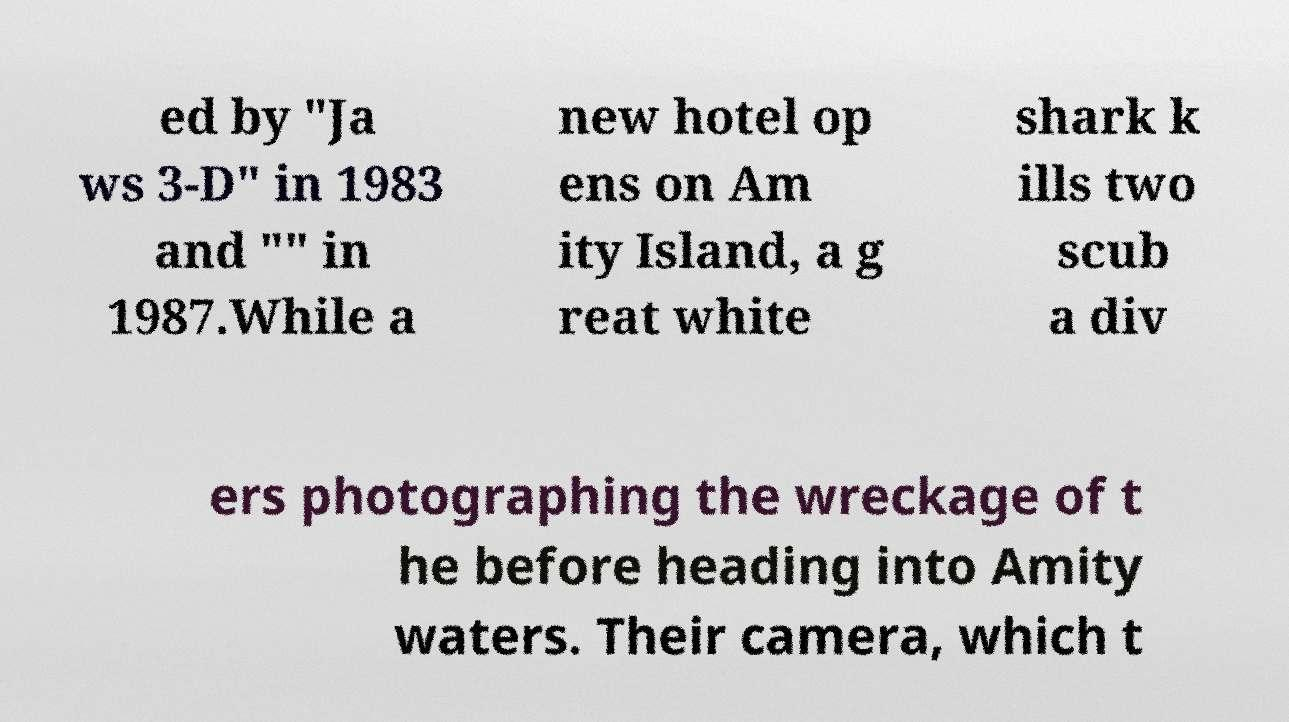Can you read and provide the text displayed in the image?This photo seems to have some interesting text. Can you extract and type it out for me? ed by "Ja ws 3-D" in 1983 and "" in 1987.While a new hotel op ens on Am ity Island, a g reat white shark k ills two scub a div ers photographing the wreckage of t he before heading into Amity waters. Their camera, which t 